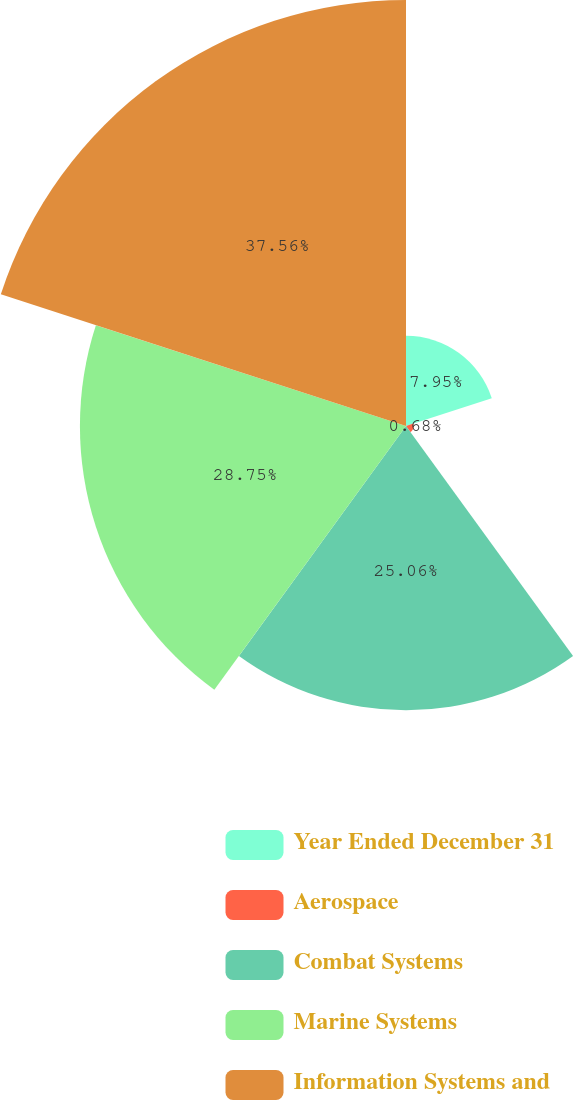Convert chart to OTSL. <chart><loc_0><loc_0><loc_500><loc_500><pie_chart><fcel>Year Ended December 31<fcel>Aerospace<fcel>Combat Systems<fcel>Marine Systems<fcel>Information Systems and<nl><fcel>7.95%<fcel>0.68%<fcel>25.06%<fcel>28.75%<fcel>37.56%<nl></chart> 